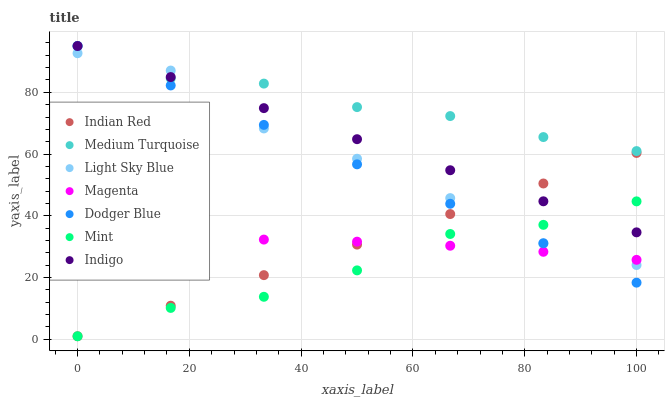Does Mint have the minimum area under the curve?
Answer yes or no. Yes. Does Medium Turquoise have the maximum area under the curve?
Answer yes or no. Yes. Does Indian Red have the minimum area under the curve?
Answer yes or no. No. Does Indian Red have the maximum area under the curve?
Answer yes or no. No. Is Indian Red the smoothest?
Answer yes or no. Yes. Is Light Sky Blue the roughest?
Answer yes or no. Yes. Is Light Sky Blue the smoothest?
Answer yes or no. No. Is Indian Red the roughest?
Answer yes or no. No. Does Indian Red have the lowest value?
Answer yes or no. Yes. Does Light Sky Blue have the lowest value?
Answer yes or no. No. Does Medium Turquoise have the highest value?
Answer yes or no. Yes. Does Indian Red have the highest value?
Answer yes or no. No. Is Magenta less than Medium Turquoise?
Answer yes or no. Yes. Is Indigo greater than Magenta?
Answer yes or no. Yes. Does Light Sky Blue intersect Indian Red?
Answer yes or no. Yes. Is Light Sky Blue less than Indian Red?
Answer yes or no. No. Is Light Sky Blue greater than Indian Red?
Answer yes or no. No. Does Magenta intersect Medium Turquoise?
Answer yes or no. No. 